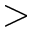Convert formula to latex. <formula><loc_0><loc_0><loc_500><loc_500>></formula> 